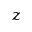<formula> <loc_0><loc_0><loc_500><loc_500>z</formula> 